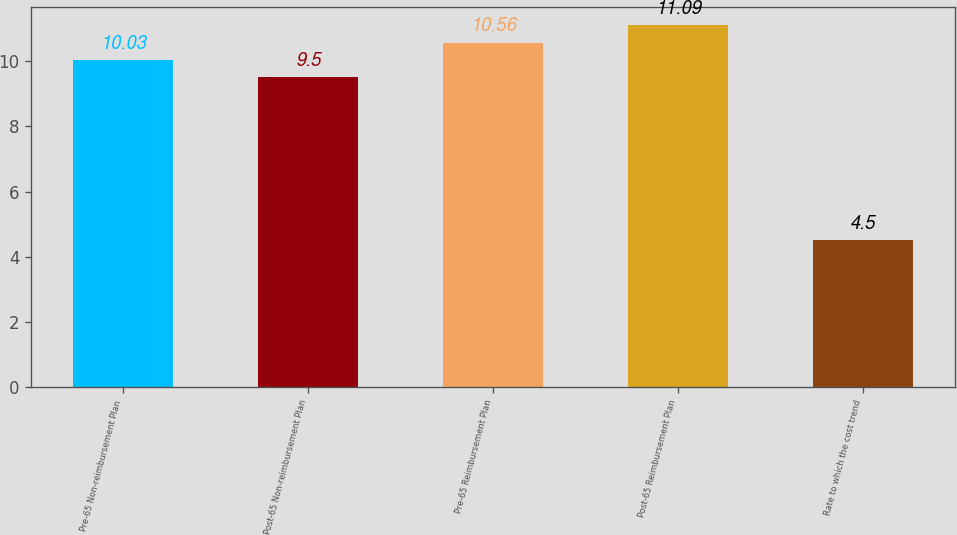Convert chart to OTSL. <chart><loc_0><loc_0><loc_500><loc_500><bar_chart><fcel>Pre-65 Non-reimbursement Plan<fcel>Post-65 Non-reimbursement Plan<fcel>Pre-65 Reimbursement Plan<fcel>Post-65 Reimbursement Plan<fcel>Rate to which the cost trend<nl><fcel>10.03<fcel>9.5<fcel>10.56<fcel>11.09<fcel>4.5<nl></chart> 